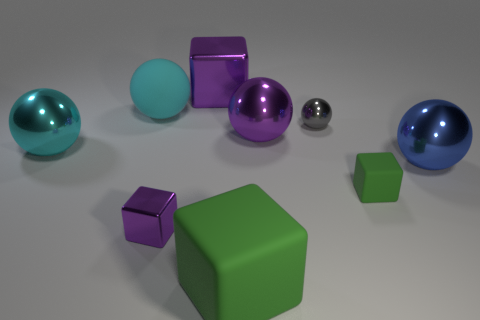Subtract all purple balls. How many purple cubes are left? 2 Add 1 small purple blocks. How many objects exist? 10 Subtract all large shiny blocks. How many blocks are left? 3 Subtract all cubes. How many objects are left? 5 Add 3 shiny things. How many shiny things are left? 9 Add 5 purple metallic balls. How many purple metallic balls exist? 6 Subtract all purple balls. How many balls are left? 4 Subtract 0 green cylinders. How many objects are left? 9 Subtract 1 spheres. How many spheres are left? 4 Subtract all brown blocks. Subtract all red balls. How many blocks are left? 4 